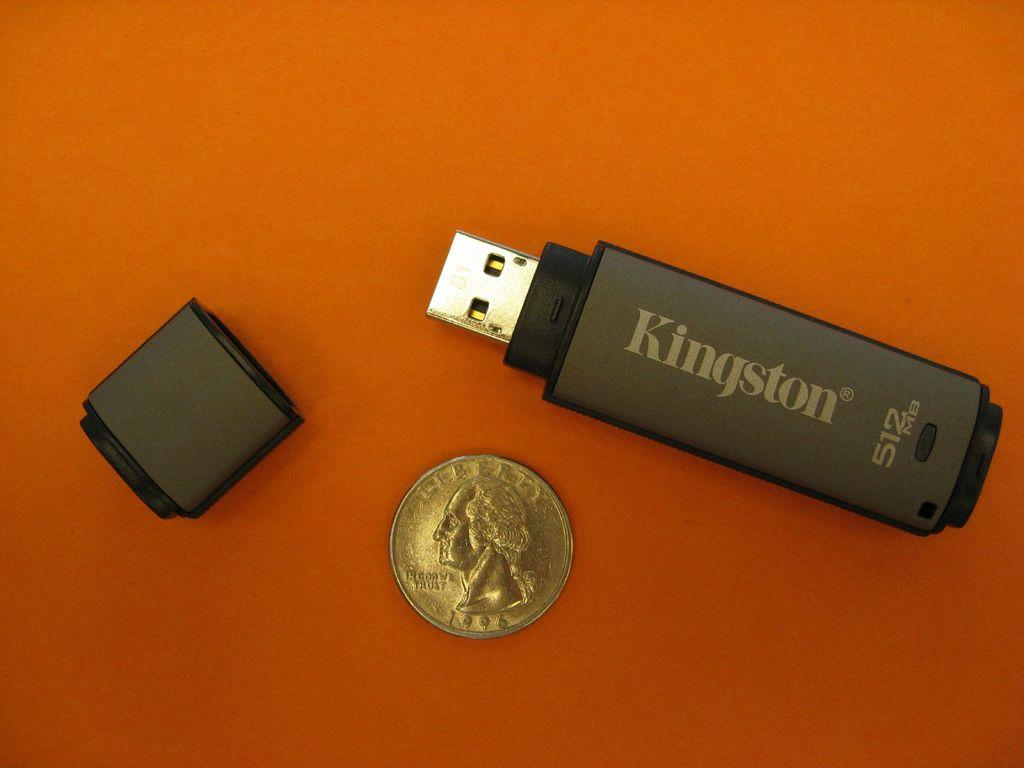Provide a one-sentence caption for the provided image. The Kingston thumb drive is a bit larger than a quarter. 